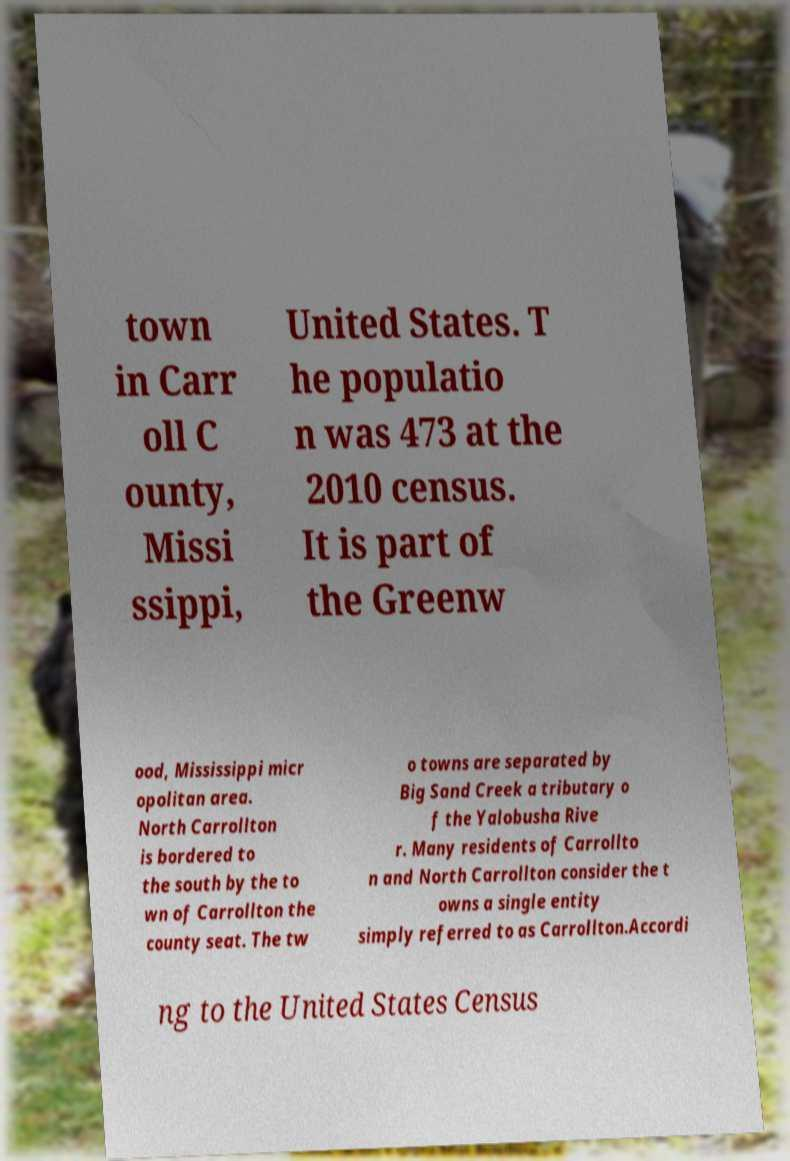There's text embedded in this image that I need extracted. Can you transcribe it verbatim? town in Carr oll C ounty, Missi ssippi, United States. T he populatio n was 473 at the 2010 census. It is part of the Greenw ood, Mississippi micr opolitan area. North Carrollton is bordered to the south by the to wn of Carrollton the county seat. The tw o towns are separated by Big Sand Creek a tributary o f the Yalobusha Rive r. Many residents of Carrollto n and North Carrollton consider the t owns a single entity simply referred to as Carrollton.Accordi ng to the United States Census 